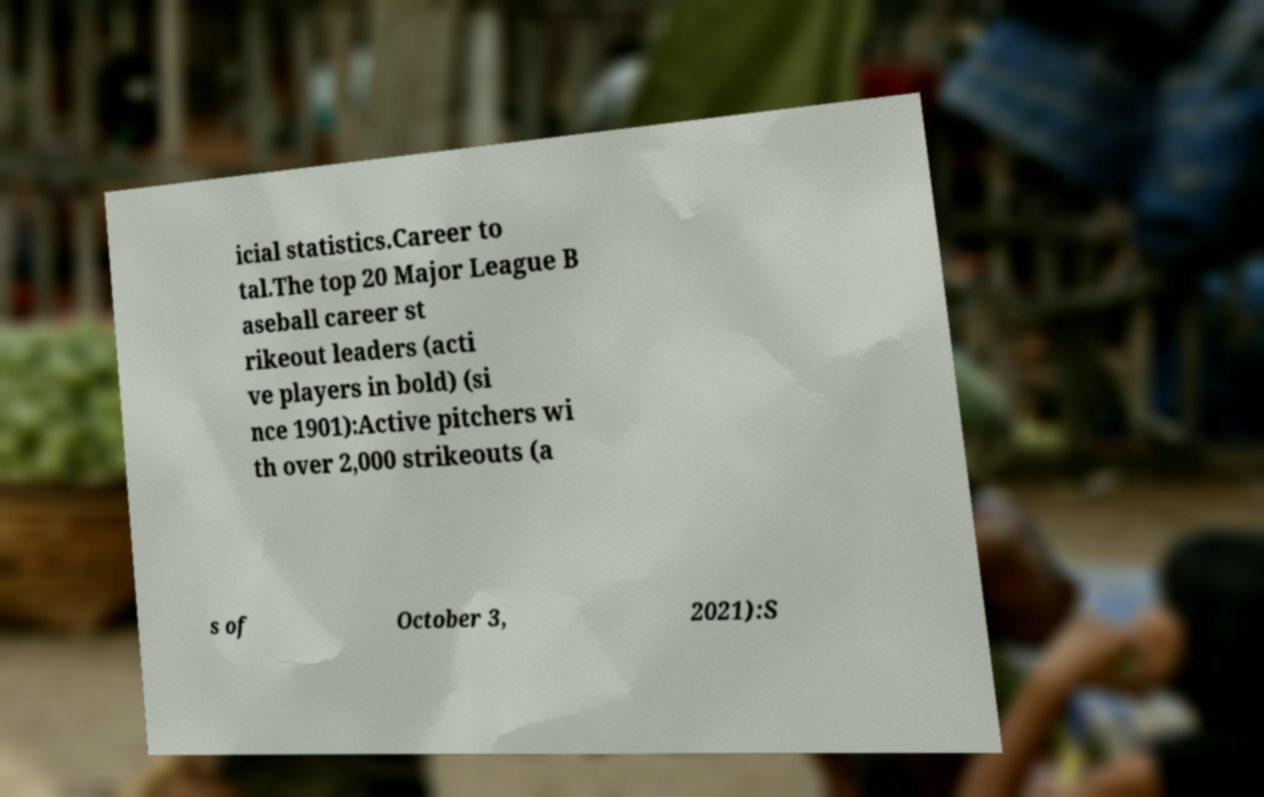What messages or text are displayed in this image? I need them in a readable, typed format. icial statistics.Career to tal.The top 20 Major League B aseball career st rikeout leaders (acti ve players in bold) (si nce 1901):Active pitchers wi th over 2,000 strikeouts (a s of October 3, 2021):S 